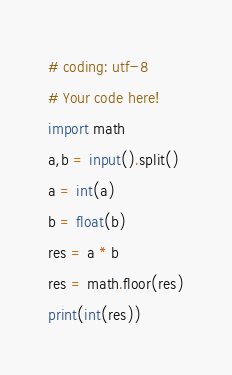Convert code to text. <code><loc_0><loc_0><loc_500><loc_500><_Python_># coding: utf-8
# Your code here!
import math
a,b = input().split()
a = int(a)
b = float(b)
res = a * b
res = math.floor(res)
print(int(res))
</code> 